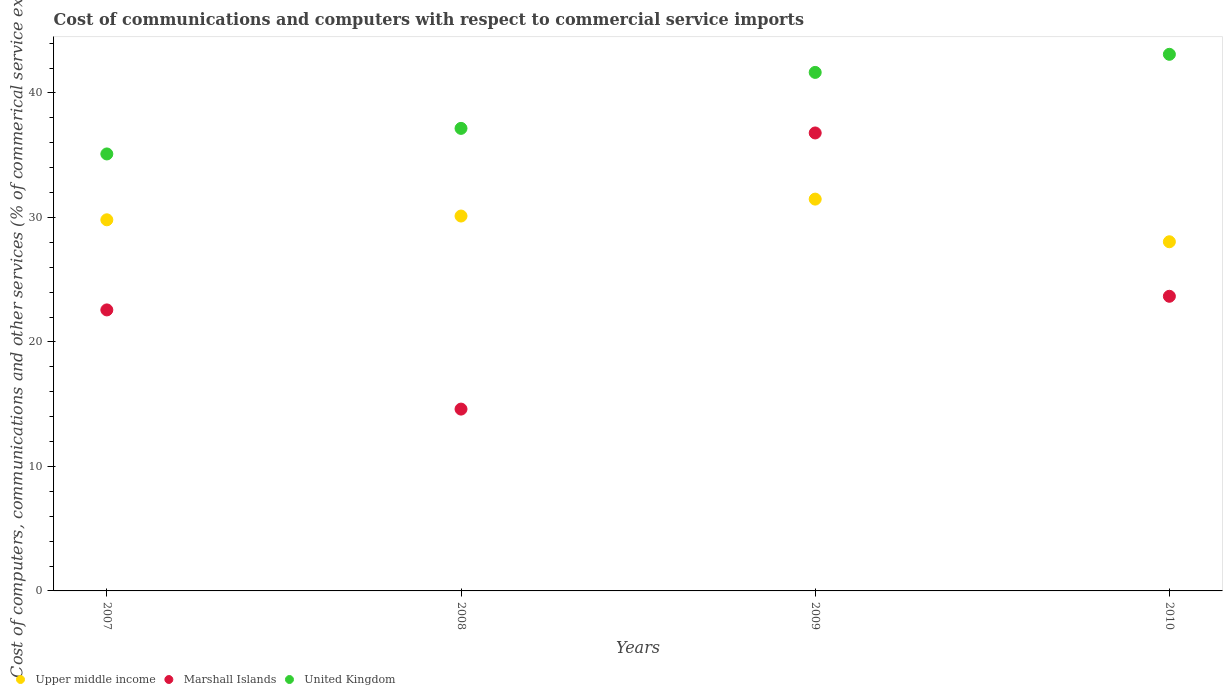What is the cost of communications and computers in Marshall Islands in 2010?
Keep it short and to the point. 23.67. Across all years, what is the maximum cost of communications and computers in Upper middle income?
Offer a very short reply. 31.47. Across all years, what is the minimum cost of communications and computers in United Kingdom?
Make the answer very short. 35.1. In which year was the cost of communications and computers in Upper middle income maximum?
Provide a short and direct response. 2009. In which year was the cost of communications and computers in Upper middle income minimum?
Give a very brief answer. 2010. What is the total cost of communications and computers in Marshall Islands in the graph?
Provide a succinct answer. 97.64. What is the difference between the cost of communications and computers in Upper middle income in 2008 and that in 2009?
Give a very brief answer. -1.36. What is the difference between the cost of communications and computers in Marshall Islands in 2010 and the cost of communications and computers in Upper middle income in 2007?
Ensure brevity in your answer.  -6.14. What is the average cost of communications and computers in Marshall Islands per year?
Give a very brief answer. 24.41. In the year 2009, what is the difference between the cost of communications and computers in United Kingdom and cost of communications and computers in Upper middle income?
Provide a short and direct response. 10.18. In how many years, is the cost of communications and computers in Marshall Islands greater than 36 %?
Keep it short and to the point. 1. What is the ratio of the cost of communications and computers in Upper middle income in 2008 to that in 2009?
Make the answer very short. 0.96. Is the cost of communications and computers in Marshall Islands in 2008 less than that in 2009?
Your answer should be very brief. Yes. What is the difference between the highest and the second highest cost of communications and computers in Upper middle income?
Ensure brevity in your answer.  1.36. What is the difference between the highest and the lowest cost of communications and computers in Marshall Islands?
Your answer should be compact. 22.18. In how many years, is the cost of communications and computers in United Kingdom greater than the average cost of communications and computers in United Kingdom taken over all years?
Provide a succinct answer. 2. Does the cost of communications and computers in United Kingdom monotonically increase over the years?
Your response must be concise. Yes. Is the cost of communications and computers in Marshall Islands strictly greater than the cost of communications and computers in Upper middle income over the years?
Provide a short and direct response. No. Is the cost of communications and computers in Marshall Islands strictly less than the cost of communications and computers in United Kingdom over the years?
Your answer should be compact. Yes. How many dotlines are there?
Offer a very short reply. 3. How many years are there in the graph?
Ensure brevity in your answer.  4. How many legend labels are there?
Offer a very short reply. 3. What is the title of the graph?
Ensure brevity in your answer.  Cost of communications and computers with respect to commercial service imports. What is the label or title of the X-axis?
Your answer should be compact. Years. What is the label or title of the Y-axis?
Your answer should be very brief. Cost of computers, communications and other services (% of commerical service exports). What is the Cost of computers, communications and other services (% of commerical service exports) of Upper middle income in 2007?
Your response must be concise. 29.81. What is the Cost of computers, communications and other services (% of commerical service exports) of Marshall Islands in 2007?
Provide a short and direct response. 22.57. What is the Cost of computers, communications and other services (% of commerical service exports) of United Kingdom in 2007?
Provide a short and direct response. 35.1. What is the Cost of computers, communications and other services (% of commerical service exports) in Upper middle income in 2008?
Make the answer very short. 30.12. What is the Cost of computers, communications and other services (% of commerical service exports) of Marshall Islands in 2008?
Offer a very short reply. 14.61. What is the Cost of computers, communications and other services (% of commerical service exports) of United Kingdom in 2008?
Make the answer very short. 37.16. What is the Cost of computers, communications and other services (% of commerical service exports) of Upper middle income in 2009?
Give a very brief answer. 31.47. What is the Cost of computers, communications and other services (% of commerical service exports) in Marshall Islands in 2009?
Give a very brief answer. 36.79. What is the Cost of computers, communications and other services (% of commerical service exports) of United Kingdom in 2009?
Provide a succinct answer. 41.65. What is the Cost of computers, communications and other services (% of commerical service exports) in Upper middle income in 2010?
Your answer should be compact. 28.05. What is the Cost of computers, communications and other services (% of commerical service exports) of Marshall Islands in 2010?
Provide a succinct answer. 23.67. What is the Cost of computers, communications and other services (% of commerical service exports) of United Kingdom in 2010?
Your answer should be compact. 43.11. Across all years, what is the maximum Cost of computers, communications and other services (% of commerical service exports) of Upper middle income?
Your answer should be very brief. 31.47. Across all years, what is the maximum Cost of computers, communications and other services (% of commerical service exports) of Marshall Islands?
Your answer should be compact. 36.79. Across all years, what is the maximum Cost of computers, communications and other services (% of commerical service exports) of United Kingdom?
Give a very brief answer. 43.11. Across all years, what is the minimum Cost of computers, communications and other services (% of commerical service exports) in Upper middle income?
Provide a succinct answer. 28.05. Across all years, what is the minimum Cost of computers, communications and other services (% of commerical service exports) of Marshall Islands?
Your answer should be compact. 14.61. Across all years, what is the minimum Cost of computers, communications and other services (% of commerical service exports) of United Kingdom?
Offer a terse response. 35.1. What is the total Cost of computers, communications and other services (% of commerical service exports) in Upper middle income in the graph?
Offer a terse response. 119.45. What is the total Cost of computers, communications and other services (% of commerical service exports) in Marshall Islands in the graph?
Your answer should be compact. 97.64. What is the total Cost of computers, communications and other services (% of commerical service exports) of United Kingdom in the graph?
Ensure brevity in your answer.  157.02. What is the difference between the Cost of computers, communications and other services (% of commerical service exports) of Upper middle income in 2007 and that in 2008?
Keep it short and to the point. -0.3. What is the difference between the Cost of computers, communications and other services (% of commerical service exports) in Marshall Islands in 2007 and that in 2008?
Provide a succinct answer. 7.97. What is the difference between the Cost of computers, communications and other services (% of commerical service exports) in United Kingdom in 2007 and that in 2008?
Your answer should be very brief. -2.05. What is the difference between the Cost of computers, communications and other services (% of commerical service exports) in Upper middle income in 2007 and that in 2009?
Ensure brevity in your answer.  -1.66. What is the difference between the Cost of computers, communications and other services (% of commerical service exports) of Marshall Islands in 2007 and that in 2009?
Your answer should be compact. -14.21. What is the difference between the Cost of computers, communications and other services (% of commerical service exports) of United Kingdom in 2007 and that in 2009?
Provide a short and direct response. -6.55. What is the difference between the Cost of computers, communications and other services (% of commerical service exports) of Upper middle income in 2007 and that in 2010?
Offer a terse response. 1.76. What is the difference between the Cost of computers, communications and other services (% of commerical service exports) of Marshall Islands in 2007 and that in 2010?
Ensure brevity in your answer.  -1.09. What is the difference between the Cost of computers, communications and other services (% of commerical service exports) of United Kingdom in 2007 and that in 2010?
Provide a short and direct response. -8. What is the difference between the Cost of computers, communications and other services (% of commerical service exports) in Upper middle income in 2008 and that in 2009?
Provide a succinct answer. -1.36. What is the difference between the Cost of computers, communications and other services (% of commerical service exports) of Marshall Islands in 2008 and that in 2009?
Ensure brevity in your answer.  -22.18. What is the difference between the Cost of computers, communications and other services (% of commerical service exports) in United Kingdom in 2008 and that in 2009?
Give a very brief answer. -4.5. What is the difference between the Cost of computers, communications and other services (% of commerical service exports) in Upper middle income in 2008 and that in 2010?
Ensure brevity in your answer.  2.07. What is the difference between the Cost of computers, communications and other services (% of commerical service exports) in Marshall Islands in 2008 and that in 2010?
Provide a succinct answer. -9.06. What is the difference between the Cost of computers, communications and other services (% of commerical service exports) of United Kingdom in 2008 and that in 2010?
Offer a terse response. -5.95. What is the difference between the Cost of computers, communications and other services (% of commerical service exports) in Upper middle income in 2009 and that in 2010?
Make the answer very short. 3.43. What is the difference between the Cost of computers, communications and other services (% of commerical service exports) of Marshall Islands in 2009 and that in 2010?
Your answer should be very brief. 13.12. What is the difference between the Cost of computers, communications and other services (% of commerical service exports) in United Kingdom in 2009 and that in 2010?
Keep it short and to the point. -1.45. What is the difference between the Cost of computers, communications and other services (% of commerical service exports) in Upper middle income in 2007 and the Cost of computers, communications and other services (% of commerical service exports) in Marshall Islands in 2008?
Provide a succinct answer. 15.21. What is the difference between the Cost of computers, communications and other services (% of commerical service exports) in Upper middle income in 2007 and the Cost of computers, communications and other services (% of commerical service exports) in United Kingdom in 2008?
Your response must be concise. -7.34. What is the difference between the Cost of computers, communications and other services (% of commerical service exports) in Marshall Islands in 2007 and the Cost of computers, communications and other services (% of commerical service exports) in United Kingdom in 2008?
Make the answer very short. -14.58. What is the difference between the Cost of computers, communications and other services (% of commerical service exports) in Upper middle income in 2007 and the Cost of computers, communications and other services (% of commerical service exports) in Marshall Islands in 2009?
Your answer should be compact. -6.98. What is the difference between the Cost of computers, communications and other services (% of commerical service exports) in Upper middle income in 2007 and the Cost of computers, communications and other services (% of commerical service exports) in United Kingdom in 2009?
Your response must be concise. -11.84. What is the difference between the Cost of computers, communications and other services (% of commerical service exports) of Marshall Islands in 2007 and the Cost of computers, communications and other services (% of commerical service exports) of United Kingdom in 2009?
Your response must be concise. -19.08. What is the difference between the Cost of computers, communications and other services (% of commerical service exports) in Upper middle income in 2007 and the Cost of computers, communications and other services (% of commerical service exports) in Marshall Islands in 2010?
Offer a terse response. 6.14. What is the difference between the Cost of computers, communications and other services (% of commerical service exports) in Upper middle income in 2007 and the Cost of computers, communications and other services (% of commerical service exports) in United Kingdom in 2010?
Provide a short and direct response. -13.29. What is the difference between the Cost of computers, communications and other services (% of commerical service exports) of Marshall Islands in 2007 and the Cost of computers, communications and other services (% of commerical service exports) of United Kingdom in 2010?
Give a very brief answer. -20.53. What is the difference between the Cost of computers, communications and other services (% of commerical service exports) of Upper middle income in 2008 and the Cost of computers, communications and other services (% of commerical service exports) of Marshall Islands in 2009?
Ensure brevity in your answer.  -6.67. What is the difference between the Cost of computers, communications and other services (% of commerical service exports) in Upper middle income in 2008 and the Cost of computers, communications and other services (% of commerical service exports) in United Kingdom in 2009?
Make the answer very short. -11.54. What is the difference between the Cost of computers, communications and other services (% of commerical service exports) in Marshall Islands in 2008 and the Cost of computers, communications and other services (% of commerical service exports) in United Kingdom in 2009?
Ensure brevity in your answer.  -27.05. What is the difference between the Cost of computers, communications and other services (% of commerical service exports) in Upper middle income in 2008 and the Cost of computers, communications and other services (% of commerical service exports) in Marshall Islands in 2010?
Offer a terse response. 6.45. What is the difference between the Cost of computers, communications and other services (% of commerical service exports) in Upper middle income in 2008 and the Cost of computers, communications and other services (% of commerical service exports) in United Kingdom in 2010?
Keep it short and to the point. -12.99. What is the difference between the Cost of computers, communications and other services (% of commerical service exports) in Marshall Islands in 2008 and the Cost of computers, communications and other services (% of commerical service exports) in United Kingdom in 2010?
Give a very brief answer. -28.5. What is the difference between the Cost of computers, communications and other services (% of commerical service exports) in Upper middle income in 2009 and the Cost of computers, communications and other services (% of commerical service exports) in Marshall Islands in 2010?
Offer a terse response. 7.81. What is the difference between the Cost of computers, communications and other services (% of commerical service exports) of Upper middle income in 2009 and the Cost of computers, communications and other services (% of commerical service exports) of United Kingdom in 2010?
Provide a short and direct response. -11.63. What is the difference between the Cost of computers, communications and other services (% of commerical service exports) in Marshall Islands in 2009 and the Cost of computers, communications and other services (% of commerical service exports) in United Kingdom in 2010?
Offer a very short reply. -6.32. What is the average Cost of computers, communications and other services (% of commerical service exports) in Upper middle income per year?
Ensure brevity in your answer.  29.86. What is the average Cost of computers, communications and other services (% of commerical service exports) of Marshall Islands per year?
Your answer should be very brief. 24.41. What is the average Cost of computers, communications and other services (% of commerical service exports) of United Kingdom per year?
Provide a succinct answer. 39.25. In the year 2007, what is the difference between the Cost of computers, communications and other services (% of commerical service exports) in Upper middle income and Cost of computers, communications and other services (% of commerical service exports) in Marshall Islands?
Provide a succinct answer. 7.24. In the year 2007, what is the difference between the Cost of computers, communications and other services (% of commerical service exports) in Upper middle income and Cost of computers, communications and other services (% of commerical service exports) in United Kingdom?
Your answer should be compact. -5.29. In the year 2007, what is the difference between the Cost of computers, communications and other services (% of commerical service exports) of Marshall Islands and Cost of computers, communications and other services (% of commerical service exports) of United Kingdom?
Give a very brief answer. -12.53. In the year 2008, what is the difference between the Cost of computers, communications and other services (% of commerical service exports) in Upper middle income and Cost of computers, communications and other services (% of commerical service exports) in Marshall Islands?
Offer a terse response. 15.51. In the year 2008, what is the difference between the Cost of computers, communications and other services (% of commerical service exports) of Upper middle income and Cost of computers, communications and other services (% of commerical service exports) of United Kingdom?
Give a very brief answer. -7.04. In the year 2008, what is the difference between the Cost of computers, communications and other services (% of commerical service exports) in Marshall Islands and Cost of computers, communications and other services (% of commerical service exports) in United Kingdom?
Give a very brief answer. -22.55. In the year 2009, what is the difference between the Cost of computers, communications and other services (% of commerical service exports) in Upper middle income and Cost of computers, communications and other services (% of commerical service exports) in Marshall Islands?
Keep it short and to the point. -5.31. In the year 2009, what is the difference between the Cost of computers, communications and other services (% of commerical service exports) of Upper middle income and Cost of computers, communications and other services (% of commerical service exports) of United Kingdom?
Give a very brief answer. -10.18. In the year 2009, what is the difference between the Cost of computers, communications and other services (% of commerical service exports) in Marshall Islands and Cost of computers, communications and other services (% of commerical service exports) in United Kingdom?
Your response must be concise. -4.86. In the year 2010, what is the difference between the Cost of computers, communications and other services (% of commerical service exports) of Upper middle income and Cost of computers, communications and other services (% of commerical service exports) of Marshall Islands?
Your answer should be compact. 4.38. In the year 2010, what is the difference between the Cost of computers, communications and other services (% of commerical service exports) of Upper middle income and Cost of computers, communications and other services (% of commerical service exports) of United Kingdom?
Your response must be concise. -15.06. In the year 2010, what is the difference between the Cost of computers, communications and other services (% of commerical service exports) of Marshall Islands and Cost of computers, communications and other services (% of commerical service exports) of United Kingdom?
Keep it short and to the point. -19.44. What is the ratio of the Cost of computers, communications and other services (% of commerical service exports) in Upper middle income in 2007 to that in 2008?
Provide a short and direct response. 0.99. What is the ratio of the Cost of computers, communications and other services (% of commerical service exports) of Marshall Islands in 2007 to that in 2008?
Your answer should be compact. 1.55. What is the ratio of the Cost of computers, communications and other services (% of commerical service exports) in United Kingdom in 2007 to that in 2008?
Keep it short and to the point. 0.94. What is the ratio of the Cost of computers, communications and other services (% of commerical service exports) in Upper middle income in 2007 to that in 2009?
Offer a very short reply. 0.95. What is the ratio of the Cost of computers, communications and other services (% of commerical service exports) in Marshall Islands in 2007 to that in 2009?
Offer a terse response. 0.61. What is the ratio of the Cost of computers, communications and other services (% of commerical service exports) in United Kingdom in 2007 to that in 2009?
Your answer should be compact. 0.84. What is the ratio of the Cost of computers, communications and other services (% of commerical service exports) of Upper middle income in 2007 to that in 2010?
Your answer should be compact. 1.06. What is the ratio of the Cost of computers, communications and other services (% of commerical service exports) in Marshall Islands in 2007 to that in 2010?
Keep it short and to the point. 0.95. What is the ratio of the Cost of computers, communications and other services (% of commerical service exports) of United Kingdom in 2007 to that in 2010?
Ensure brevity in your answer.  0.81. What is the ratio of the Cost of computers, communications and other services (% of commerical service exports) of Upper middle income in 2008 to that in 2009?
Your answer should be compact. 0.96. What is the ratio of the Cost of computers, communications and other services (% of commerical service exports) of Marshall Islands in 2008 to that in 2009?
Give a very brief answer. 0.4. What is the ratio of the Cost of computers, communications and other services (% of commerical service exports) in United Kingdom in 2008 to that in 2009?
Make the answer very short. 0.89. What is the ratio of the Cost of computers, communications and other services (% of commerical service exports) of Upper middle income in 2008 to that in 2010?
Offer a very short reply. 1.07. What is the ratio of the Cost of computers, communications and other services (% of commerical service exports) of Marshall Islands in 2008 to that in 2010?
Offer a terse response. 0.62. What is the ratio of the Cost of computers, communications and other services (% of commerical service exports) in United Kingdom in 2008 to that in 2010?
Offer a very short reply. 0.86. What is the ratio of the Cost of computers, communications and other services (% of commerical service exports) in Upper middle income in 2009 to that in 2010?
Give a very brief answer. 1.12. What is the ratio of the Cost of computers, communications and other services (% of commerical service exports) of Marshall Islands in 2009 to that in 2010?
Offer a terse response. 1.55. What is the ratio of the Cost of computers, communications and other services (% of commerical service exports) of United Kingdom in 2009 to that in 2010?
Give a very brief answer. 0.97. What is the difference between the highest and the second highest Cost of computers, communications and other services (% of commerical service exports) in Upper middle income?
Offer a terse response. 1.36. What is the difference between the highest and the second highest Cost of computers, communications and other services (% of commerical service exports) of Marshall Islands?
Keep it short and to the point. 13.12. What is the difference between the highest and the second highest Cost of computers, communications and other services (% of commerical service exports) of United Kingdom?
Your response must be concise. 1.45. What is the difference between the highest and the lowest Cost of computers, communications and other services (% of commerical service exports) of Upper middle income?
Give a very brief answer. 3.43. What is the difference between the highest and the lowest Cost of computers, communications and other services (% of commerical service exports) in Marshall Islands?
Offer a terse response. 22.18. What is the difference between the highest and the lowest Cost of computers, communications and other services (% of commerical service exports) in United Kingdom?
Your response must be concise. 8. 